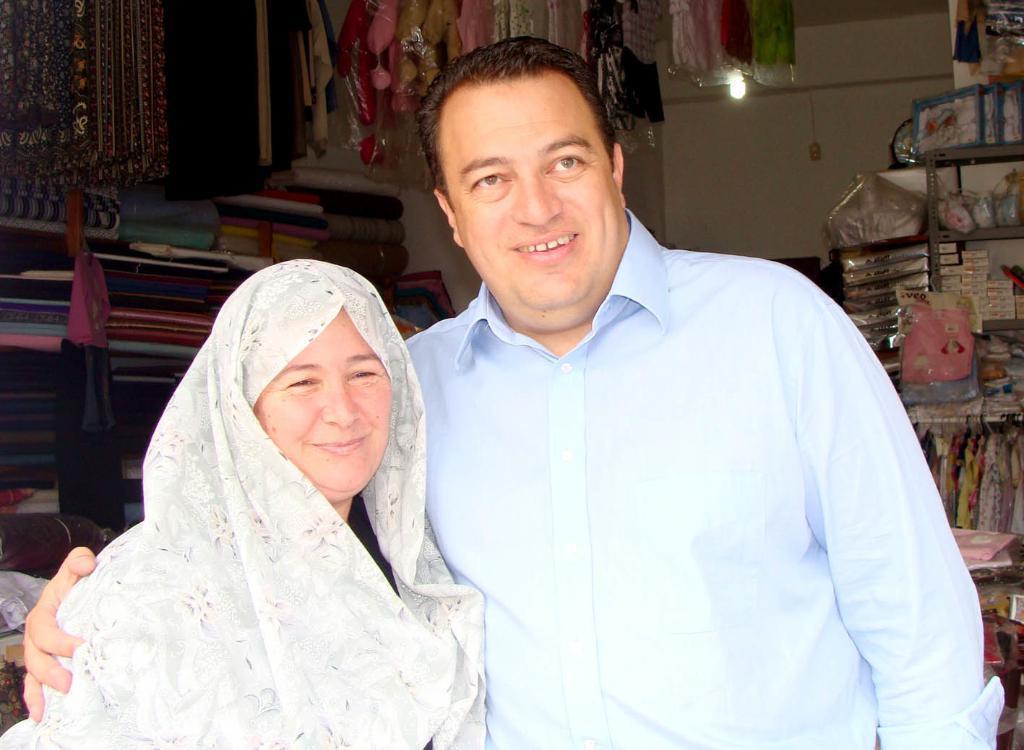Please provide a concise description of this image. In this image I can see a person wearing blue colored shirt and a woman wearing black and white colored dress are standing and smiling. In the background I can see a rack, few objects in the rack, few clothes in the rack, few clothes hanged to the top, the white colored wall and a light. 